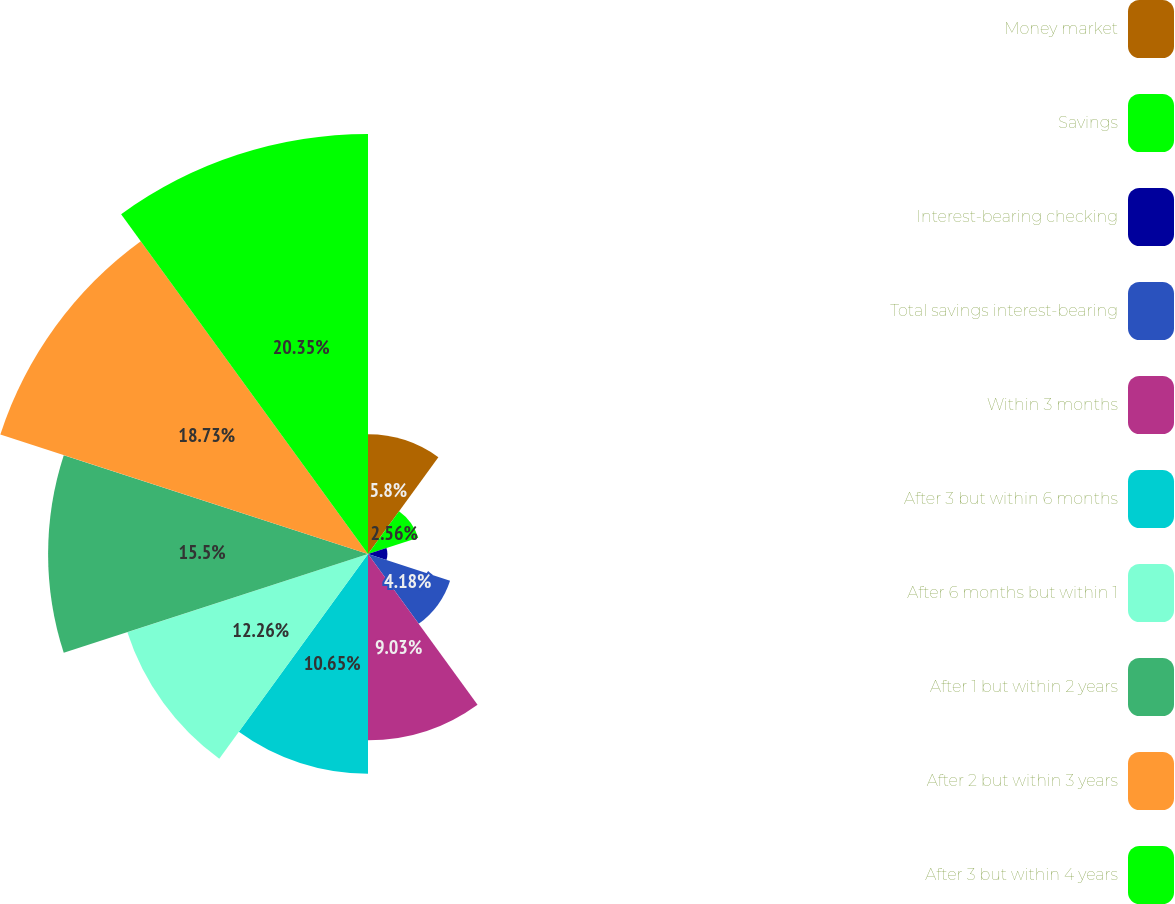Convert chart to OTSL. <chart><loc_0><loc_0><loc_500><loc_500><pie_chart><fcel>Money market<fcel>Savings<fcel>Interest-bearing checking<fcel>Total savings interest-bearing<fcel>Within 3 months<fcel>After 3 but within 6 months<fcel>After 6 months but within 1<fcel>After 1 but within 2 years<fcel>After 2 but within 3 years<fcel>After 3 but within 4 years<nl><fcel>5.8%<fcel>2.56%<fcel>0.94%<fcel>4.18%<fcel>9.03%<fcel>10.65%<fcel>12.26%<fcel>15.5%<fcel>18.73%<fcel>20.35%<nl></chart> 